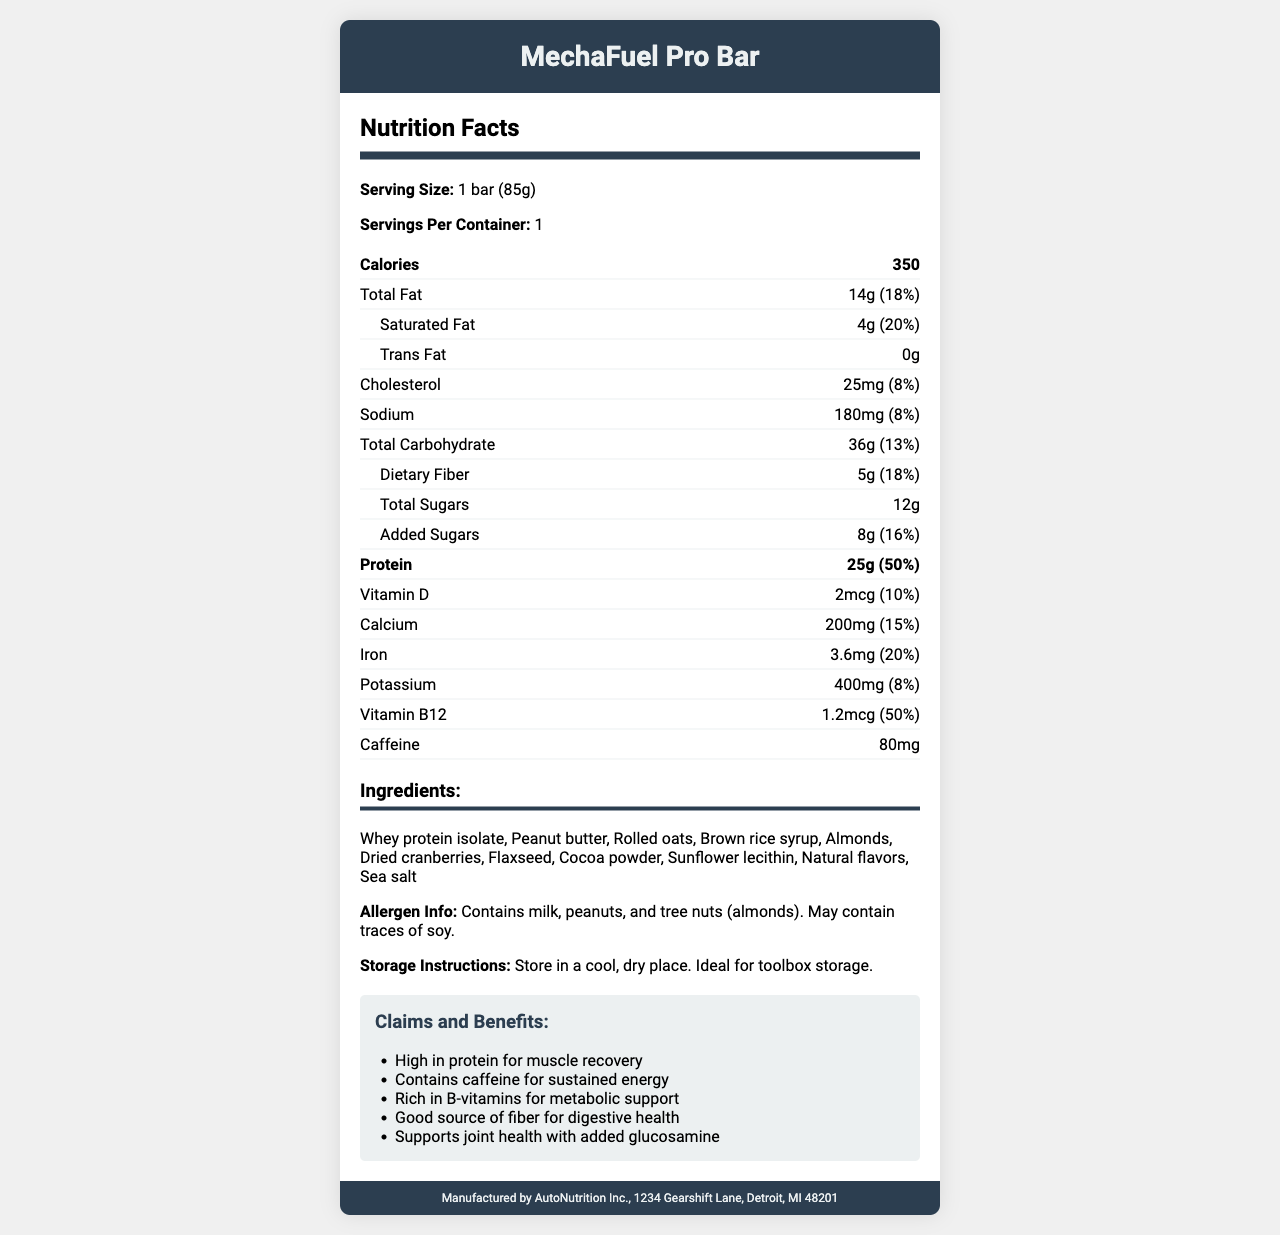What is the product name? The product name is provided at the top of the document and in the title section.
Answer: MechaFuel Pro Bar How many servings are in one container? The serving size information states "Servings Per Container: 1".
Answer: 1 How much protein is in one bar? In the nutrition items section, it is stated that there is 25 grams of protein, which is 50% of the daily value (DV).
Answer: 25g (50% DV) What allergens are present in the MechaFuel Pro Bar? This information is found in the "Allergen Info" section.
Answer: Milk, peanuts, and tree nuts (almonds). May contain traces of soy. What is the daily value percentage for dietary fiber in this bar? The nutrition information section lists dietary fiber as providing 18% of the daily value.
Answer: 18% How many calories are in one MechaFuel Pro Bar? The nutrition facts list the caloric content as 350 calories per serving.
Answer: 350 What are the main ingredients of the MechaFuel Pro Bar? The ingredients are detailed in the "Ingredients" section.
Answer: Whey protein isolate, Peanut butter, Rolled oats, Brown rice syrup, Almonds, Dried cranberries, Flaxseed, Cocoa powder, Sunflower lecithin, Natural flavors, and Sea salt. Is there any trans fat in this protein bar? The nutrition facts section explicitly states "Trans Fat: 0g".
Answer: No What is the caffeine content of the MechaFuel Pro Bar? The caffeine content is listed in the nutrition facts section as 80mg.
Answer: 80mg What is the purpose of the high protein content in the MechaFuel Pro Bar? A. Energy boost B. Muscle recovery C. Flavor enhancement D. Reducing calorie consumption The "Claims and Benefits" section mentions that the high protein content is for muscle recovery.
Answer: B. Muscle recovery How much calcium is in this protein bar? A. 100mg B. 150mg C. 200mg D. 250mg The amount of calcium is detailed in the nutrition facts section as 200mg, providing 15% of the daily value.
Answer: C. 200mg Does the MechaFuel Pro Bar contain vitamin D? The nutrition facts section lists vitamin D content as 2mcg, providing 10% of the daily value.
Answer: Yes Summarize the key nutritional and allergen information for MechaFuel Pro Bar. The document provides detailed nutritional information including macro-nutrient content, as well as micronutrients and caffeine content. It also includes specific allergen information and storage instructions. The claims highlight the benefits relevant to its target user group.
Answer: The MechaFuel Pro Bar is a high-protein (25g) energy bar designed for mechanics working long hours. It contains 350 calories per serving, with 14g of total fat (including 4g of saturated fat), 36g of carbohydrates (including 5g of dietary fiber and 12g of sugars), and 80mg of caffeine. The bar also provides several vitamins and minerals, including 50% of the daily value for vitamin B12 and 15% for calcium. Allergen information indicates it contains milk, peanuts, and tree nuts (almonds), and may contain traces of soy. Where is AutoNutrition Inc. located? The manufacturer's information section provides the location.
Answer: 1234 Gearshift Lane, Detroit, MI 48201 Can you list the storage instructions for the MechaFuel Pro Bar? The storage instructions are detailed at the bottom of the main description section.
Answer: Store in a cool, dry place. Ideal for toolbox storage. Does the MechaFuel Pro Bar contain any glucosamine? The document does not provide specific information on the presence of glucosamine. It mentions joint health support but does not elaborate on the ingredients providing it.
Answer: Cannot be determined 